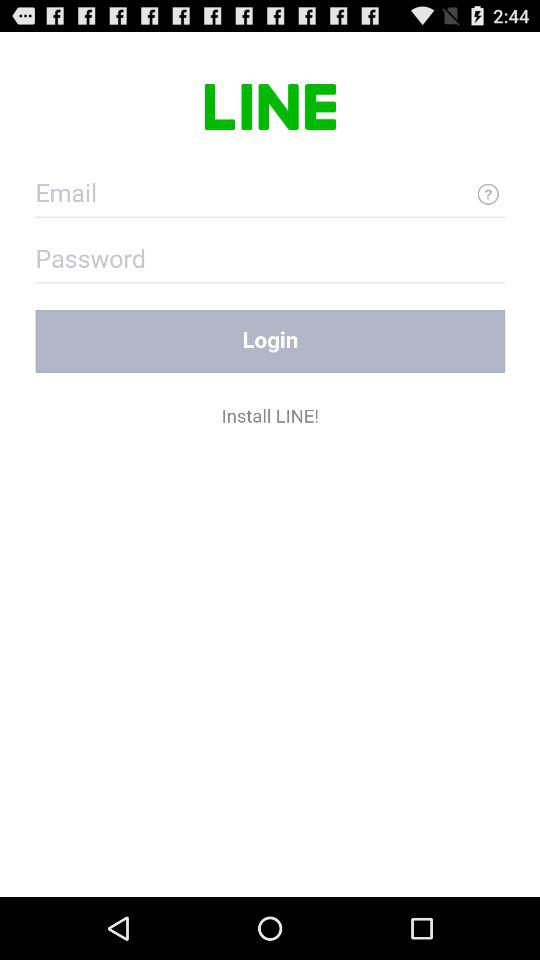What is the name of the application? The name of the application is "LINE". 